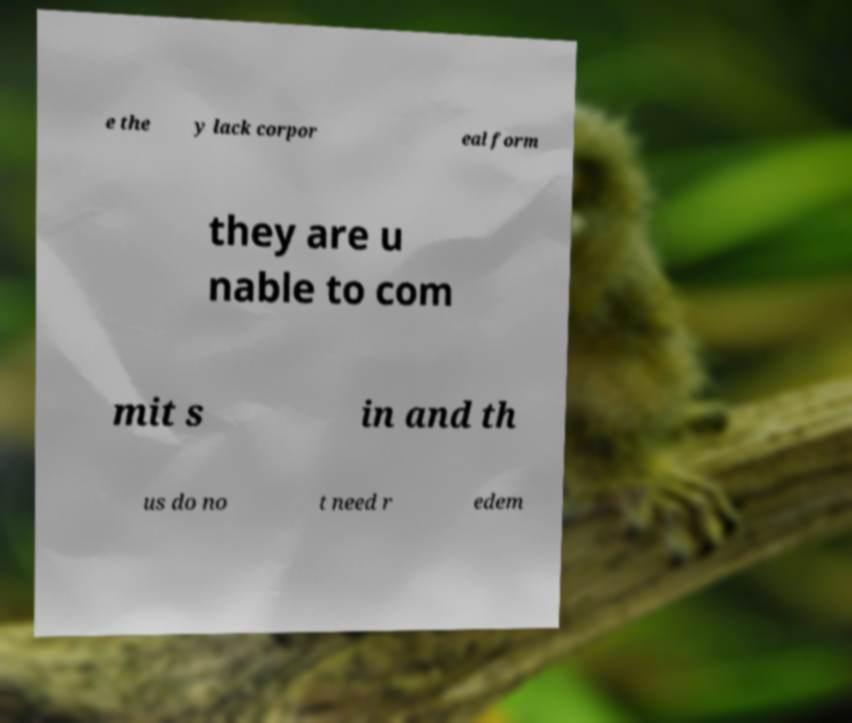Can you read and provide the text displayed in the image?This photo seems to have some interesting text. Can you extract and type it out for me? e the y lack corpor eal form they are u nable to com mit s in and th us do no t need r edem 